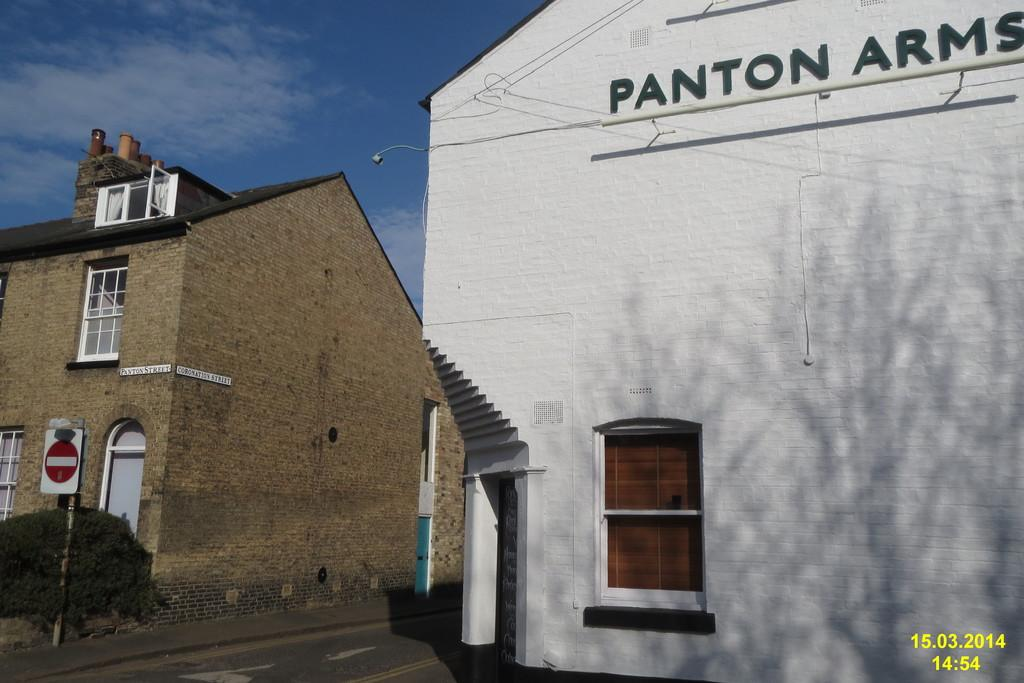<image>
Relay a brief, clear account of the picture shown. A building has Panton Arms visible in black letters. 